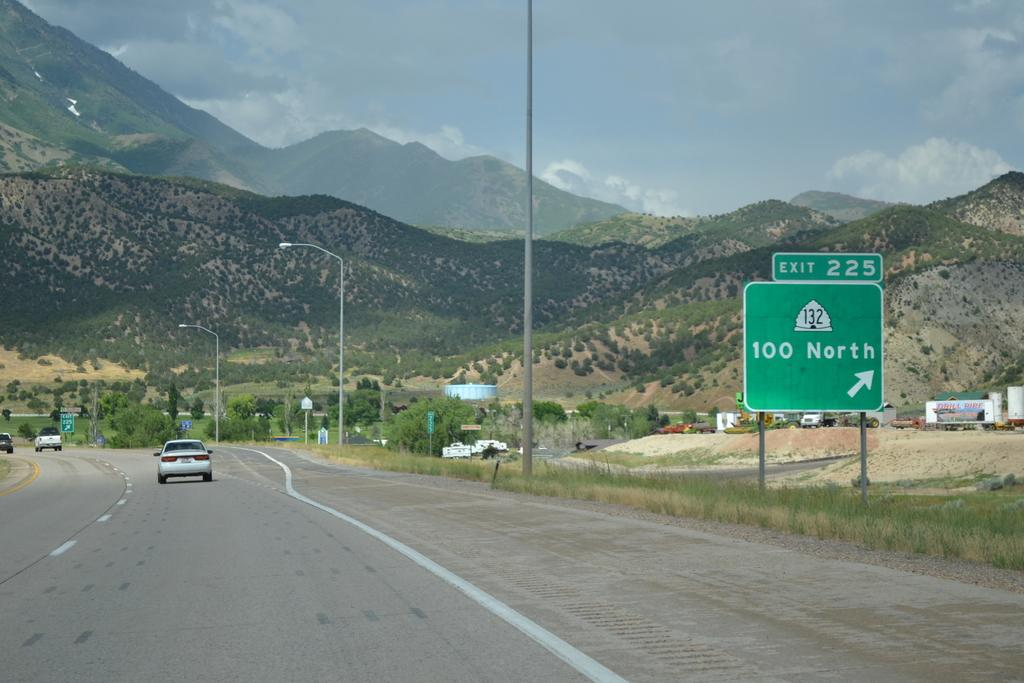<image>
Summarize the visual content of the image. a road with a sign that says 100 north on it 